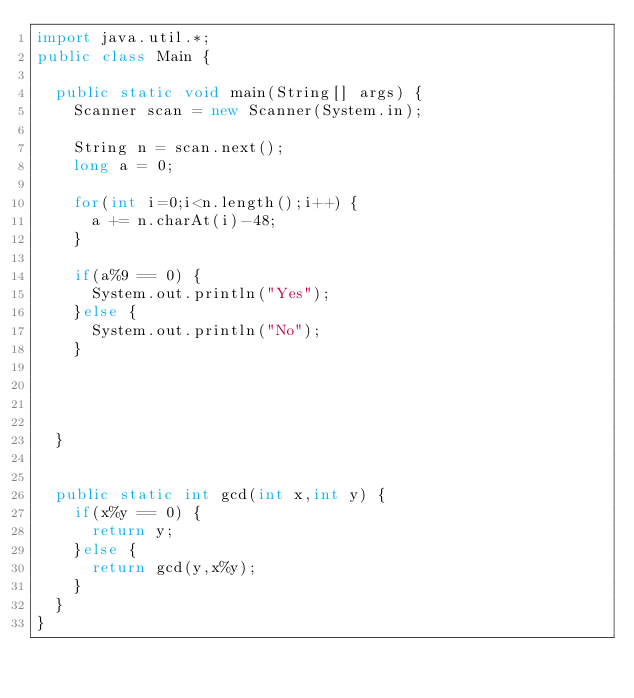Convert code to text. <code><loc_0><loc_0><loc_500><loc_500><_Java_>import java.util.*;
public class Main {

	public static void main(String[] args) {
		Scanner scan = new Scanner(System.in);
		
		String n = scan.next();
		long a = 0;
		
		for(int i=0;i<n.length();i++) {
			a += n.charAt(i)-48;
		}
		
		if(a%9 == 0) {
			System.out.println("Yes");
		}else {
			System.out.println("No");
		}
		
		
		
		
	}
	
	
	public static int gcd(int x,int y) {
		if(x%y == 0) {
			return y;
		}else {
			return gcd(y,x%y);
		}
	}
}
 





</code> 